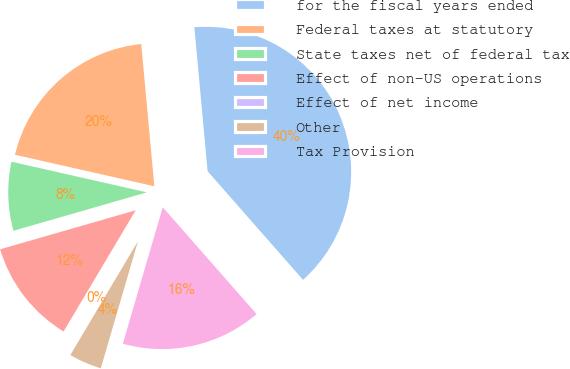<chart> <loc_0><loc_0><loc_500><loc_500><pie_chart><fcel>for the fiscal years ended<fcel>Federal taxes at statutory<fcel>State taxes net of federal tax<fcel>Effect of non-US operations<fcel>Effect of net income<fcel>Other<fcel>Tax Provision<nl><fcel>39.99%<fcel>20.0%<fcel>8.0%<fcel>12.0%<fcel>0.01%<fcel>4.0%<fcel>16.0%<nl></chart> 